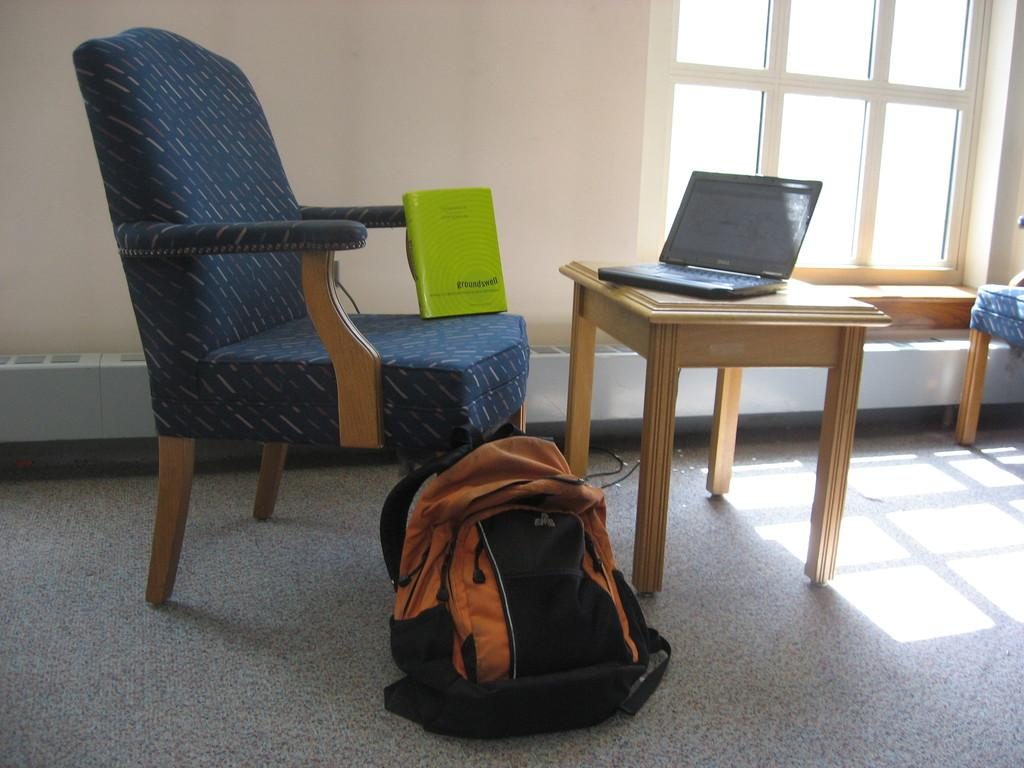What piece of furniture is in the image? There is a chair in the image. What is placed on the chair? A book is placed on the chair. What electronic device is on the table? There is a laptop on a table. What is on the floor in the image? There is a bag on the floor. Can you describe another piece of furniture in the image? There is another chair in the corner of the image. What type of cream is being used to plot a graph on the laptop? There is no cream or graph-plotting activity present in the image. The image only shows a chair with a book, a laptop on a table, a bag on the floor, and another chair in the corner. 